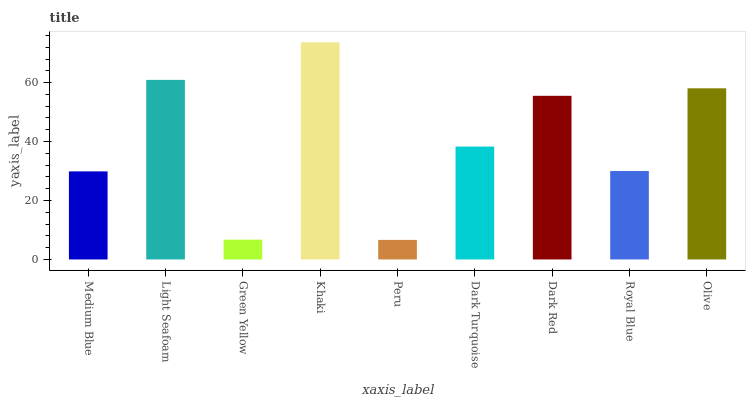Is Peru the minimum?
Answer yes or no. Yes. Is Khaki the maximum?
Answer yes or no. Yes. Is Light Seafoam the minimum?
Answer yes or no. No. Is Light Seafoam the maximum?
Answer yes or no. No. Is Light Seafoam greater than Medium Blue?
Answer yes or no. Yes. Is Medium Blue less than Light Seafoam?
Answer yes or no. Yes. Is Medium Blue greater than Light Seafoam?
Answer yes or no. No. Is Light Seafoam less than Medium Blue?
Answer yes or no. No. Is Dark Turquoise the high median?
Answer yes or no. Yes. Is Dark Turquoise the low median?
Answer yes or no. Yes. Is Royal Blue the high median?
Answer yes or no. No. Is Green Yellow the low median?
Answer yes or no. No. 